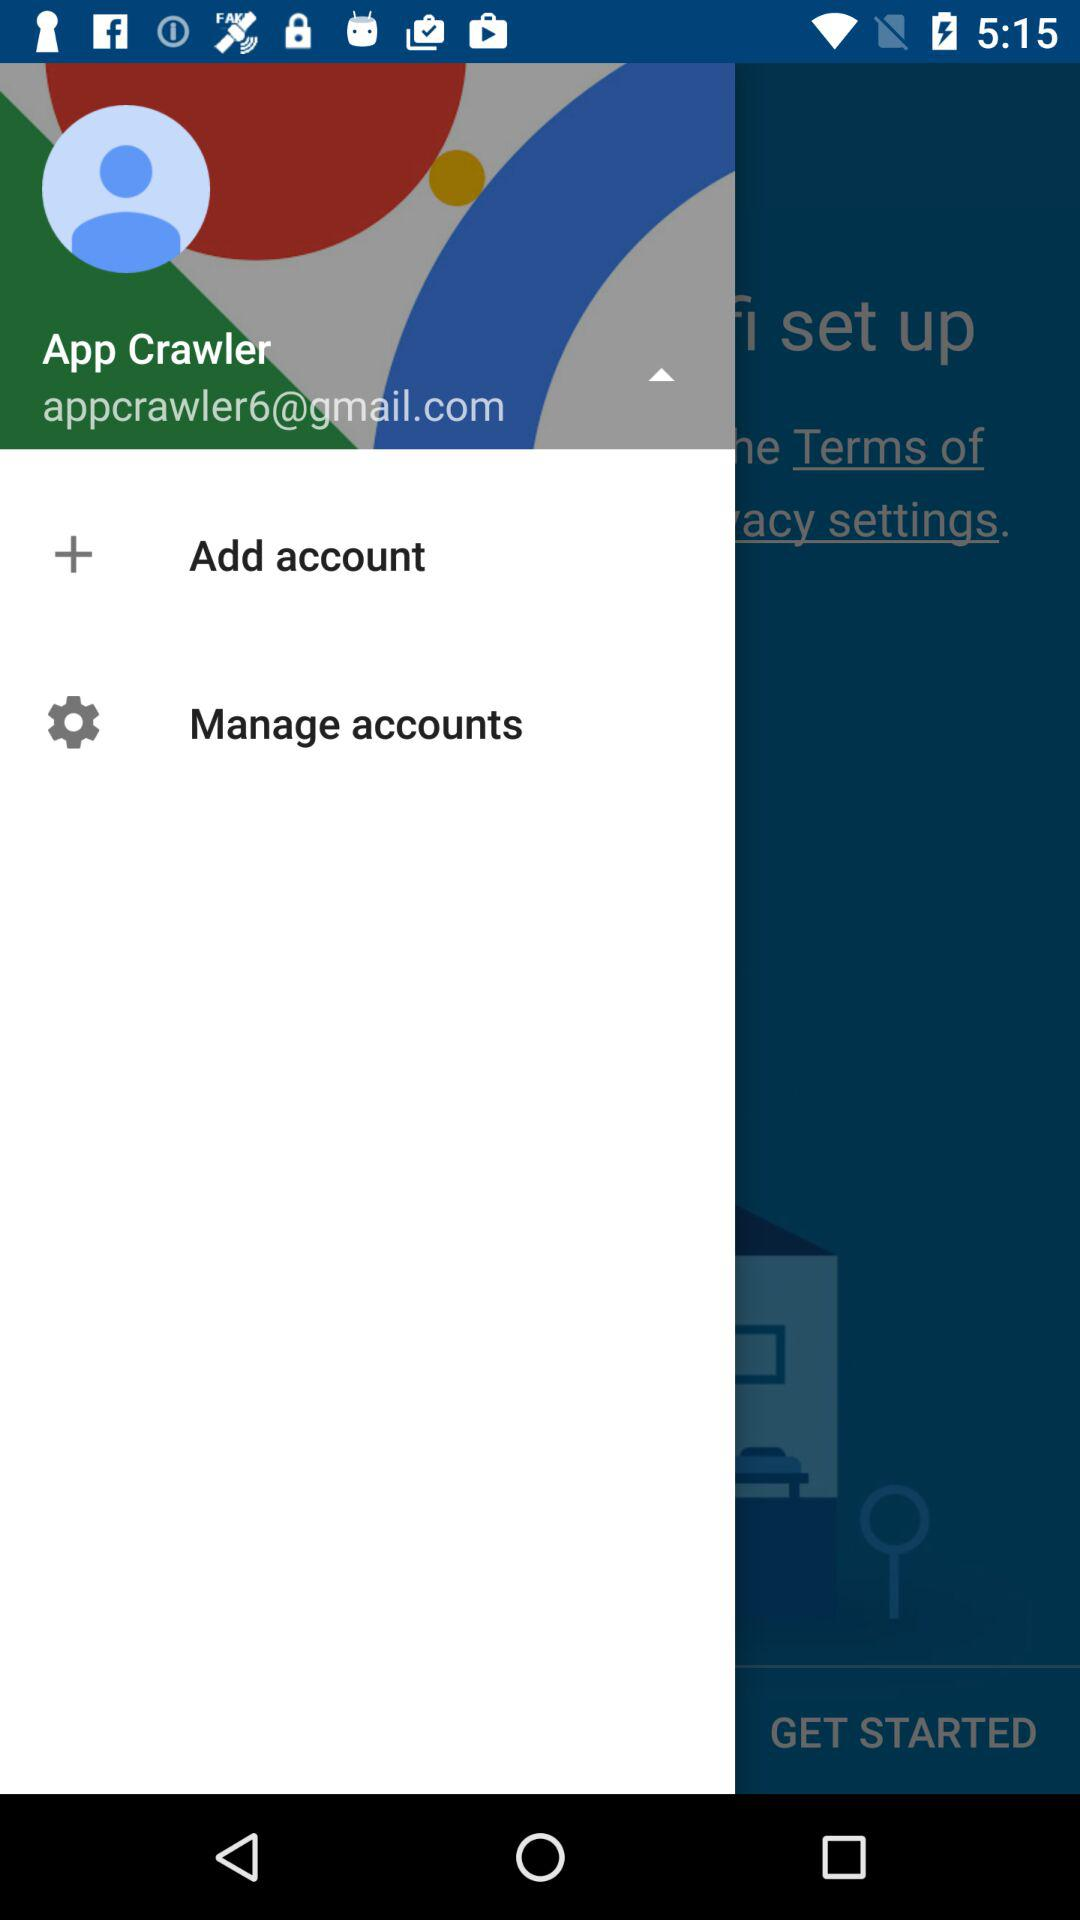What is the email address? The email address is "appcrawler6@gmail.com". 